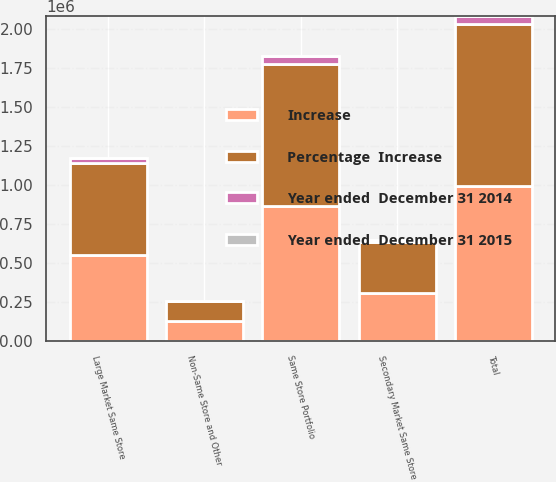Convert chart. <chart><loc_0><loc_0><loc_500><loc_500><stacked_bar_chart><ecel><fcel>Large Market Same Store<fcel>Secondary Market Same Store<fcel>Same Store Portfolio<fcel>Non-Same Store and Other<fcel>Total<nl><fcel>Percentage  Increase<fcel>587896<fcel>324771<fcel>912667<fcel>130112<fcel>1.04278e+06<nl><fcel>Increase<fcel>553038<fcel>310281<fcel>863319<fcel>128859<fcel>992178<nl><fcel>Year ended  December 31 2014<fcel>34858<fcel>14490<fcel>49348<fcel>1253<fcel>50601<nl><fcel>Year ended  December 31 2015<fcel>6.3<fcel>4.7<fcel>5.7<fcel>1<fcel>5.1<nl></chart> 